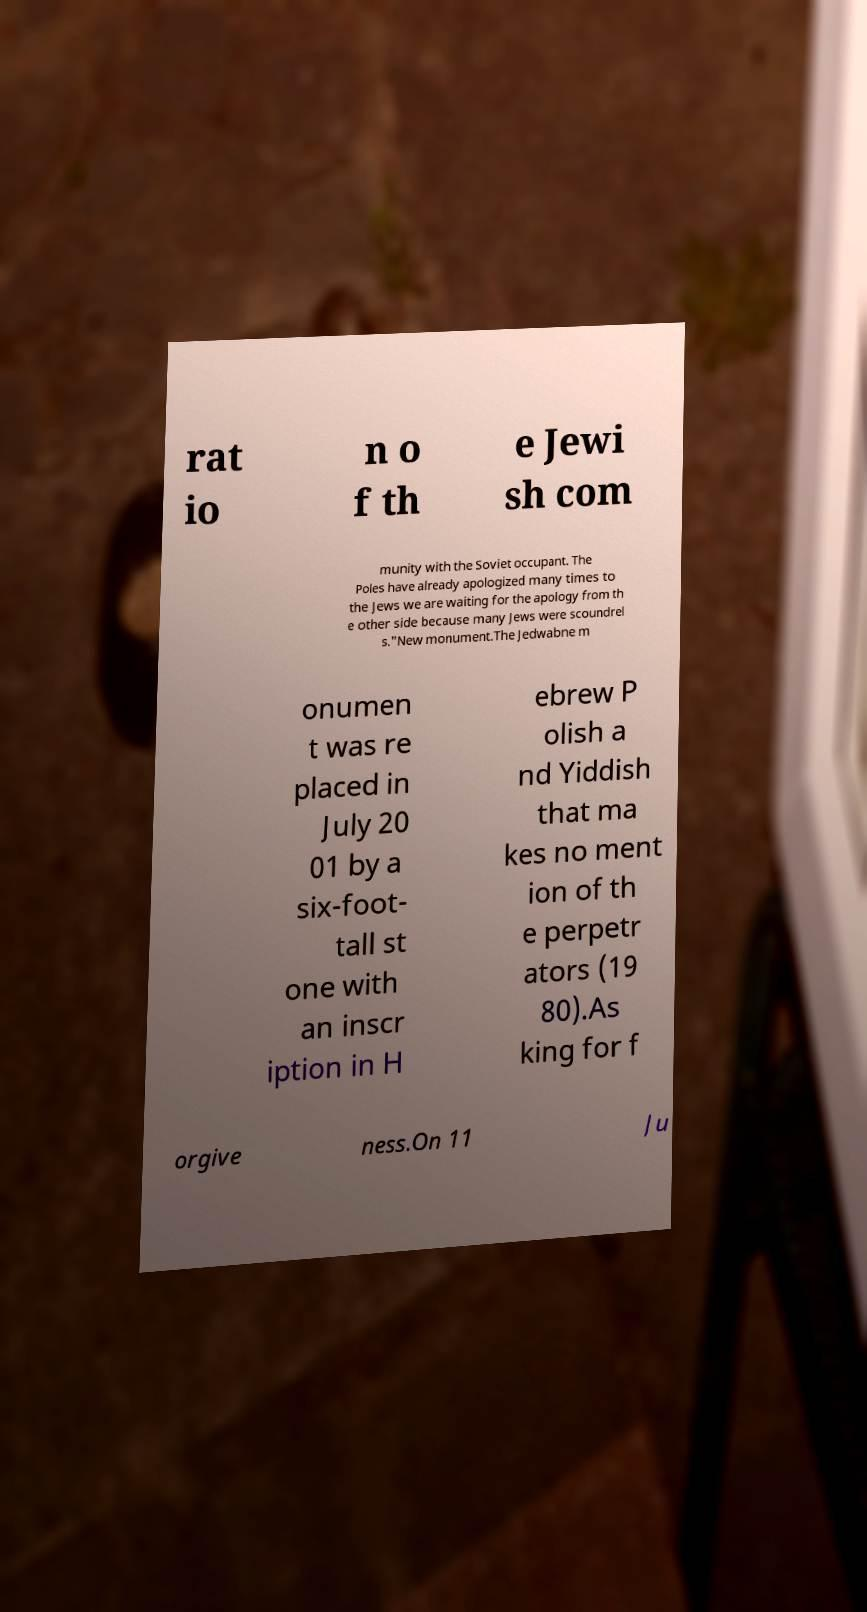For documentation purposes, I need the text within this image transcribed. Could you provide that? rat io n o f th e Jewi sh com munity with the Soviet occupant. The Poles have already apologized many times to the Jews we are waiting for the apology from th e other side because many Jews were scoundrel s."New monument.The Jedwabne m onumen t was re placed in July 20 01 by a six-foot- tall st one with an inscr iption in H ebrew P olish a nd Yiddish that ma kes no ment ion of th e perpetr ators (19 80).As king for f orgive ness.On 11 Ju 